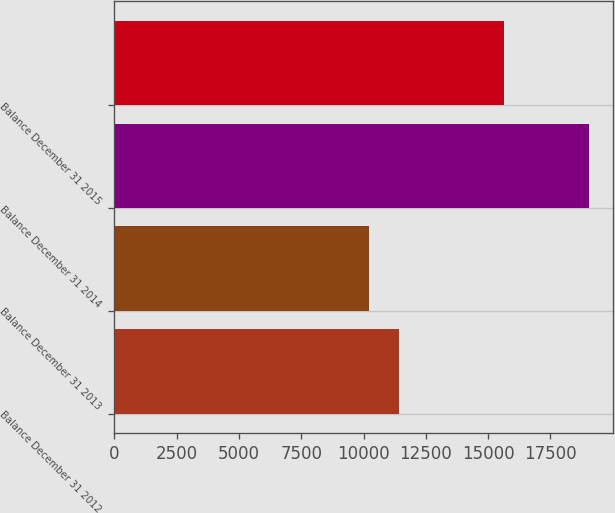Convert chart to OTSL. <chart><loc_0><loc_0><loc_500><loc_500><bar_chart><fcel>Balance December 31 2012<fcel>Balance December 31 2013<fcel>Balance December 31 2014<fcel>Balance December 31 2015<nl><fcel>11433<fcel>10231<fcel>19047<fcel>15627<nl></chart> 